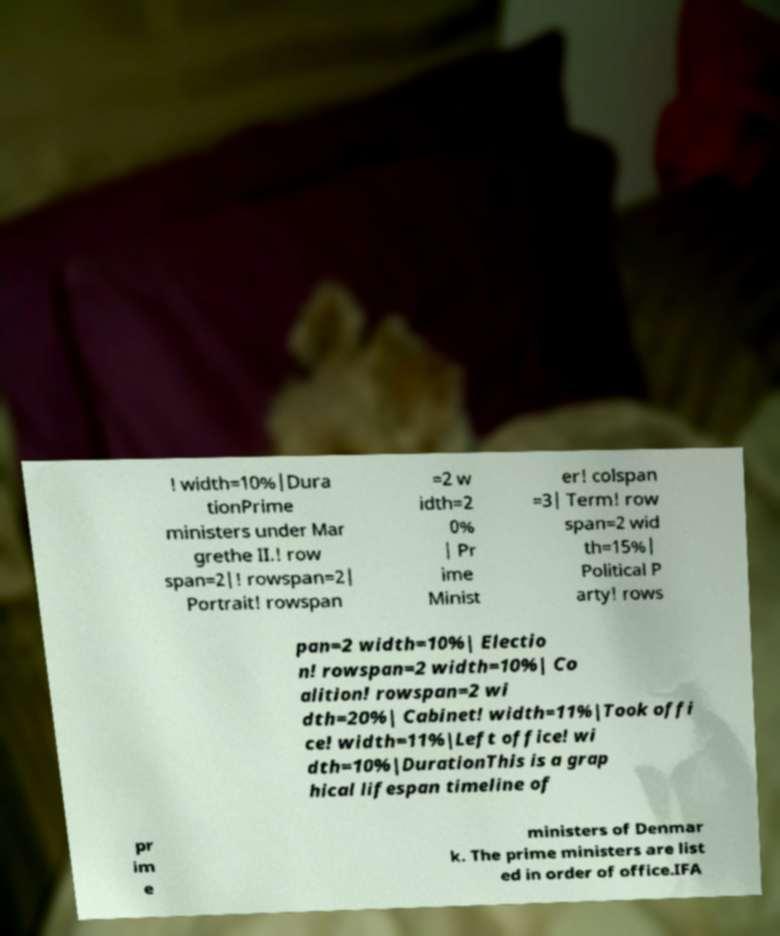Could you assist in decoding the text presented in this image and type it out clearly? ! width=10%|Dura tionPrime ministers under Mar grethe II.! row span=2|! rowspan=2| Portrait! rowspan =2 w idth=2 0% | Pr ime Minist er! colspan =3| Term! row span=2 wid th=15%| Political P arty! rows pan=2 width=10%| Electio n! rowspan=2 width=10%| Co alition! rowspan=2 wi dth=20%| Cabinet! width=11%|Took offi ce! width=11%|Left office! wi dth=10%|DurationThis is a grap hical lifespan timeline of pr im e ministers of Denmar k. The prime ministers are list ed in order of office.IFA 